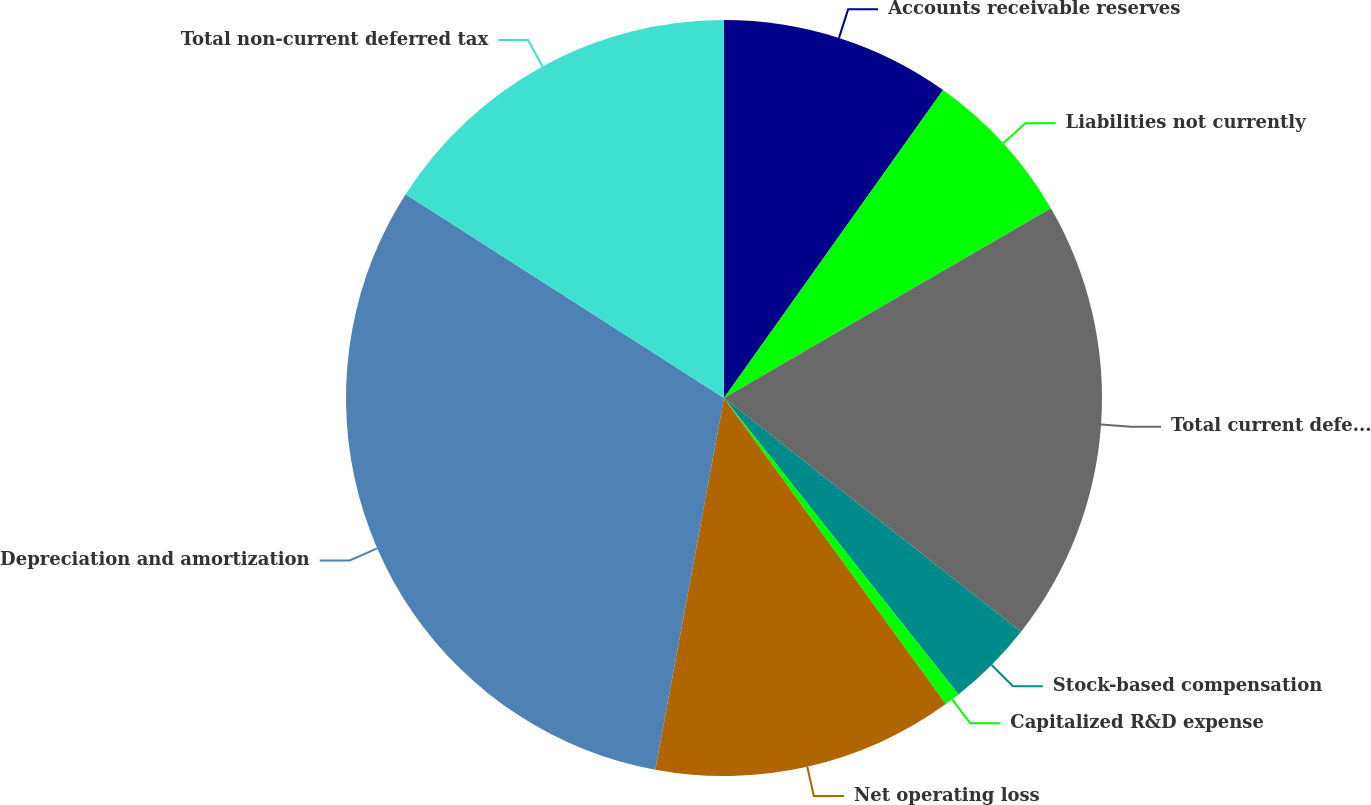Convert chart to OTSL. <chart><loc_0><loc_0><loc_500><loc_500><pie_chart><fcel>Accounts receivable reserves<fcel>Liabilities not currently<fcel>Total current deferred tax<fcel>Stock-based compensation<fcel>Capitalized R&D expense<fcel>Net operating loss<fcel>Depreciation and amortization<fcel>Total non-current deferred tax<nl><fcel>9.84%<fcel>6.79%<fcel>18.98%<fcel>3.74%<fcel>0.67%<fcel>12.89%<fcel>31.15%<fcel>15.94%<nl></chart> 